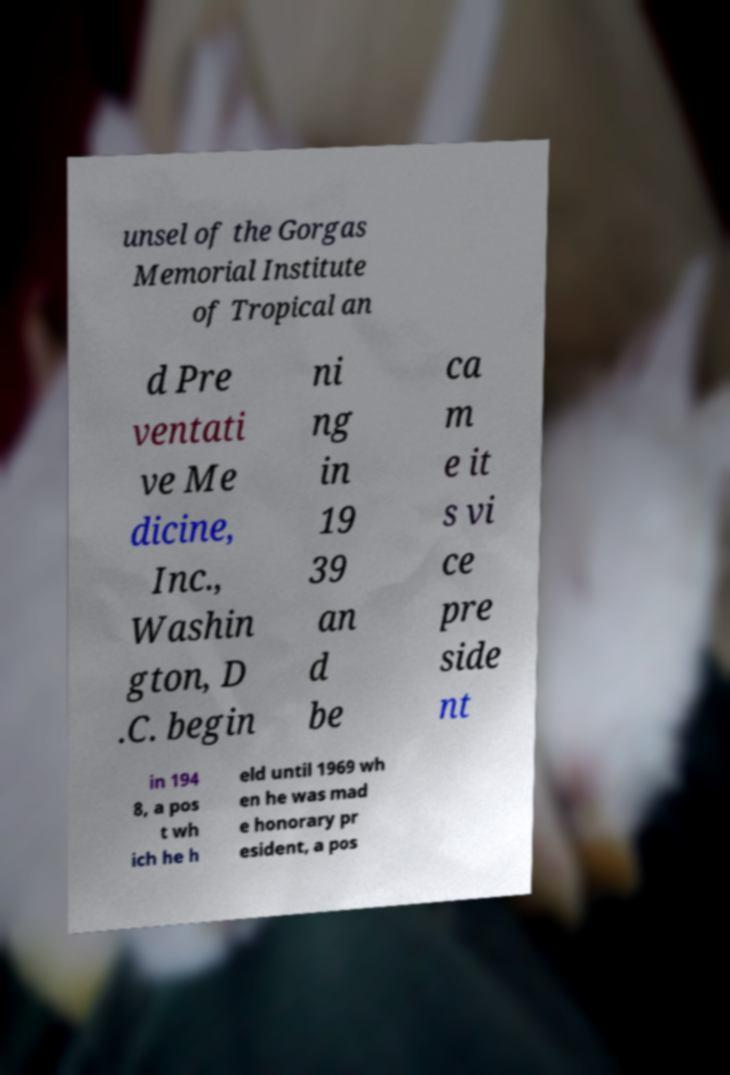I need the written content from this picture converted into text. Can you do that? unsel of the Gorgas Memorial Institute of Tropical an d Pre ventati ve Me dicine, Inc., Washin gton, D .C. begin ni ng in 19 39 an d be ca m e it s vi ce pre side nt in 194 8, a pos t wh ich he h eld until 1969 wh en he was mad e honorary pr esident, a pos 